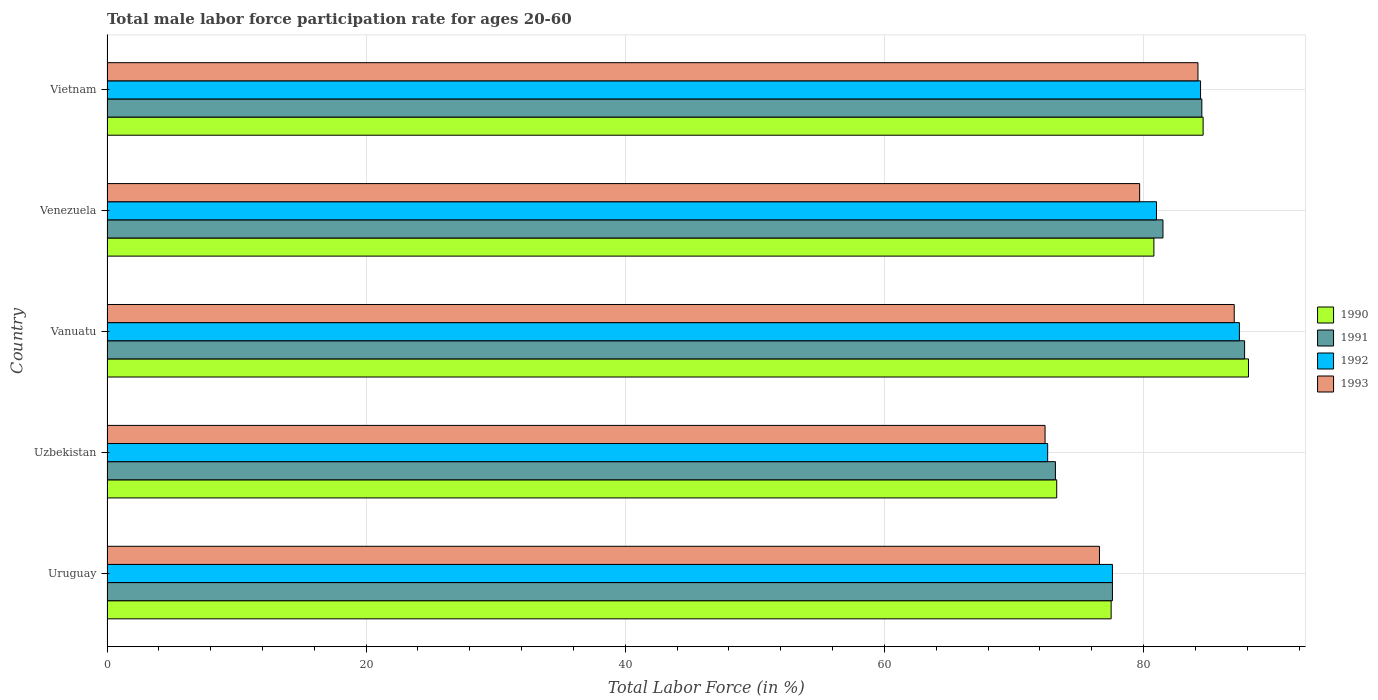How many bars are there on the 2nd tick from the top?
Provide a short and direct response. 4. What is the label of the 3rd group of bars from the top?
Ensure brevity in your answer.  Vanuatu. What is the male labor force participation rate in 1991 in Vietnam?
Make the answer very short. 84.5. Across all countries, what is the maximum male labor force participation rate in 1992?
Offer a very short reply. 87.4. Across all countries, what is the minimum male labor force participation rate in 1991?
Your response must be concise. 73.2. In which country was the male labor force participation rate in 1991 maximum?
Give a very brief answer. Vanuatu. In which country was the male labor force participation rate in 1992 minimum?
Provide a succinct answer. Uzbekistan. What is the total male labor force participation rate in 1993 in the graph?
Provide a succinct answer. 399.9. What is the difference between the male labor force participation rate in 1991 in Uruguay and that in Venezuela?
Keep it short and to the point. -3.9. What is the difference between the male labor force participation rate in 1990 in Venezuela and the male labor force participation rate in 1991 in Vietnam?
Provide a short and direct response. -3.7. What is the average male labor force participation rate in 1991 per country?
Offer a very short reply. 80.92. What is the difference between the male labor force participation rate in 1992 and male labor force participation rate in 1990 in Uruguay?
Your answer should be compact. 0.1. In how many countries, is the male labor force participation rate in 1991 greater than 72 %?
Provide a succinct answer. 5. What is the ratio of the male labor force participation rate in 1993 in Uzbekistan to that in Vietnam?
Your answer should be compact. 0.86. Is the difference between the male labor force participation rate in 1992 in Uruguay and Venezuela greater than the difference between the male labor force participation rate in 1990 in Uruguay and Venezuela?
Offer a very short reply. No. What is the difference between the highest and the second highest male labor force participation rate in 1991?
Provide a short and direct response. 3.3. What is the difference between the highest and the lowest male labor force participation rate in 1992?
Make the answer very short. 14.8. In how many countries, is the male labor force participation rate in 1992 greater than the average male labor force participation rate in 1992 taken over all countries?
Your response must be concise. 3. Is the sum of the male labor force participation rate in 1993 in Uzbekistan and Vanuatu greater than the maximum male labor force participation rate in 1991 across all countries?
Make the answer very short. Yes. Is it the case that in every country, the sum of the male labor force participation rate in 1990 and male labor force participation rate in 1992 is greater than the sum of male labor force participation rate in 1993 and male labor force participation rate in 1991?
Make the answer very short. No. What does the 3rd bar from the bottom in Vietnam represents?
Offer a terse response. 1992. Is it the case that in every country, the sum of the male labor force participation rate in 1993 and male labor force participation rate in 1990 is greater than the male labor force participation rate in 1992?
Make the answer very short. Yes. How many bars are there?
Offer a very short reply. 20. Are all the bars in the graph horizontal?
Keep it short and to the point. Yes. Are the values on the major ticks of X-axis written in scientific E-notation?
Your answer should be compact. No. Does the graph contain any zero values?
Provide a succinct answer. No. Where does the legend appear in the graph?
Ensure brevity in your answer.  Center right. How are the legend labels stacked?
Your response must be concise. Vertical. What is the title of the graph?
Give a very brief answer. Total male labor force participation rate for ages 20-60. Does "1987" appear as one of the legend labels in the graph?
Make the answer very short. No. What is the Total Labor Force (in %) in 1990 in Uruguay?
Make the answer very short. 77.5. What is the Total Labor Force (in %) of 1991 in Uruguay?
Offer a terse response. 77.6. What is the Total Labor Force (in %) in 1992 in Uruguay?
Make the answer very short. 77.6. What is the Total Labor Force (in %) in 1993 in Uruguay?
Your answer should be compact. 76.6. What is the Total Labor Force (in %) in 1990 in Uzbekistan?
Your response must be concise. 73.3. What is the Total Labor Force (in %) of 1991 in Uzbekistan?
Ensure brevity in your answer.  73.2. What is the Total Labor Force (in %) of 1992 in Uzbekistan?
Make the answer very short. 72.6. What is the Total Labor Force (in %) of 1993 in Uzbekistan?
Your answer should be compact. 72.4. What is the Total Labor Force (in %) in 1990 in Vanuatu?
Your response must be concise. 88.1. What is the Total Labor Force (in %) of 1991 in Vanuatu?
Your answer should be very brief. 87.8. What is the Total Labor Force (in %) in 1992 in Vanuatu?
Give a very brief answer. 87.4. What is the Total Labor Force (in %) of 1993 in Vanuatu?
Ensure brevity in your answer.  87. What is the Total Labor Force (in %) in 1990 in Venezuela?
Your response must be concise. 80.8. What is the Total Labor Force (in %) in 1991 in Venezuela?
Offer a terse response. 81.5. What is the Total Labor Force (in %) in 1992 in Venezuela?
Offer a very short reply. 81. What is the Total Labor Force (in %) in 1993 in Venezuela?
Your answer should be compact. 79.7. What is the Total Labor Force (in %) in 1990 in Vietnam?
Your response must be concise. 84.6. What is the Total Labor Force (in %) in 1991 in Vietnam?
Offer a very short reply. 84.5. What is the Total Labor Force (in %) of 1992 in Vietnam?
Offer a terse response. 84.4. What is the Total Labor Force (in %) of 1993 in Vietnam?
Provide a short and direct response. 84.2. Across all countries, what is the maximum Total Labor Force (in %) of 1990?
Provide a short and direct response. 88.1. Across all countries, what is the maximum Total Labor Force (in %) in 1991?
Your response must be concise. 87.8. Across all countries, what is the maximum Total Labor Force (in %) of 1992?
Ensure brevity in your answer.  87.4. Across all countries, what is the minimum Total Labor Force (in %) of 1990?
Your response must be concise. 73.3. Across all countries, what is the minimum Total Labor Force (in %) in 1991?
Your response must be concise. 73.2. Across all countries, what is the minimum Total Labor Force (in %) of 1992?
Offer a terse response. 72.6. Across all countries, what is the minimum Total Labor Force (in %) in 1993?
Your answer should be very brief. 72.4. What is the total Total Labor Force (in %) in 1990 in the graph?
Your answer should be very brief. 404.3. What is the total Total Labor Force (in %) of 1991 in the graph?
Your answer should be very brief. 404.6. What is the total Total Labor Force (in %) in 1992 in the graph?
Keep it short and to the point. 403. What is the total Total Labor Force (in %) of 1993 in the graph?
Ensure brevity in your answer.  399.9. What is the difference between the Total Labor Force (in %) of 1990 in Uruguay and that in Uzbekistan?
Your response must be concise. 4.2. What is the difference between the Total Labor Force (in %) of 1992 in Uruguay and that in Uzbekistan?
Ensure brevity in your answer.  5. What is the difference between the Total Labor Force (in %) in 1993 in Uruguay and that in Uzbekistan?
Give a very brief answer. 4.2. What is the difference between the Total Labor Force (in %) of 1990 in Uruguay and that in Vanuatu?
Keep it short and to the point. -10.6. What is the difference between the Total Labor Force (in %) of 1991 in Uruguay and that in Vanuatu?
Provide a short and direct response. -10.2. What is the difference between the Total Labor Force (in %) of 1992 in Uruguay and that in Vanuatu?
Give a very brief answer. -9.8. What is the difference between the Total Labor Force (in %) of 1993 in Uruguay and that in Vanuatu?
Make the answer very short. -10.4. What is the difference between the Total Labor Force (in %) of 1992 in Uruguay and that in Venezuela?
Offer a very short reply. -3.4. What is the difference between the Total Labor Force (in %) of 1993 in Uruguay and that in Venezuela?
Provide a short and direct response. -3.1. What is the difference between the Total Labor Force (in %) in 1990 in Uruguay and that in Vietnam?
Make the answer very short. -7.1. What is the difference between the Total Labor Force (in %) of 1992 in Uruguay and that in Vietnam?
Give a very brief answer. -6.8. What is the difference between the Total Labor Force (in %) in 1993 in Uruguay and that in Vietnam?
Ensure brevity in your answer.  -7.6. What is the difference between the Total Labor Force (in %) in 1990 in Uzbekistan and that in Vanuatu?
Make the answer very short. -14.8. What is the difference between the Total Labor Force (in %) in 1991 in Uzbekistan and that in Vanuatu?
Provide a short and direct response. -14.6. What is the difference between the Total Labor Force (in %) in 1992 in Uzbekistan and that in Vanuatu?
Keep it short and to the point. -14.8. What is the difference between the Total Labor Force (in %) of 1993 in Uzbekistan and that in Vanuatu?
Ensure brevity in your answer.  -14.6. What is the difference between the Total Labor Force (in %) of 1991 in Uzbekistan and that in Venezuela?
Make the answer very short. -8.3. What is the difference between the Total Labor Force (in %) in 1993 in Uzbekistan and that in Venezuela?
Your answer should be very brief. -7.3. What is the difference between the Total Labor Force (in %) of 1990 in Uzbekistan and that in Vietnam?
Offer a terse response. -11.3. What is the difference between the Total Labor Force (in %) in 1991 in Uzbekistan and that in Vietnam?
Offer a very short reply. -11.3. What is the difference between the Total Labor Force (in %) of 1992 in Uzbekistan and that in Vietnam?
Offer a very short reply. -11.8. What is the difference between the Total Labor Force (in %) of 1993 in Uzbekistan and that in Vietnam?
Make the answer very short. -11.8. What is the difference between the Total Labor Force (in %) in 1990 in Vanuatu and that in Venezuela?
Offer a terse response. 7.3. What is the difference between the Total Labor Force (in %) of 1991 in Vanuatu and that in Venezuela?
Make the answer very short. 6.3. What is the difference between the Total Labor Force (in %) of 1993 in Vanuatu and that in Venezuela?
Provide a succinct answer. 7.3. What is the difference between the Total Labor Force (in %) in 1990 in Vanuatu and that in Vietnam?
Your answer should be compact. 3.5. What is the difference between the Total Labor Force (in %) of 1991 in Vanuatu and that in Vietnam?
Your answer should be very brief. 3.3. What is the difference between the Total Labor Force (in %) of 1992 in Vanuatu and that in Vietnam?
Make the answer very short. 3. What is the difference between the Total Labor Force (in %) in 1993 in Vanuatu and that in Vietnam?
Keep it short and to the point. 2.8. What is the difference between the Total Labor Force (in %) of 1990 in Venezuela and that in Vietnam?
Give a very brief answer. -3.8. What is the difference between the Total Labor Force (in %) in 1991 in Venezuela and that in Vietnam?
Provide a succinct answer. -3. What is the difference between the Total Labor Force (in %) in 1992 in Venezuela and that in Vietnam?
Ensure brevity in your answer.  -3.4. What is the difference between the Total Labor Force (in %) in 1993 in Venezuela and that in Vietnam?
Keep it short and to the point. -4.5. What is the difference between the Total Labor Force (in %) of 1990 in Uruguay and the Total Labor Force (in %) of 1992 in Uzbekistan?
Provide a short and direct response. 4.9. What is the difference between the Total Labor Force (in %) in 1991 in Uruguay and the Total Labor Force (in %) in 1992 in Uzbekistan?
Keep it short and to the point. 5. What is the difference between the Total Labor Force (in %) in 1992 in Uruguay and the Total Labor Force (in %) in 1993 in Uzbekistan?
Make the answer very short. 5.2. What is the difference between the Total Labor Force (in %) of 1991 in Uruguay and the Total Labor Force (in %) of 1993 in Vanuatu?
Offer a very short reply. -9.4. What is the difference between the Total Labor Force (in %) of 1990 in Uruguay and the Total Labor Force (in %) of 1991 in Venezuela?
Your answer should be compact. -4. What is the difference between the Total Labor Force (in %) in 1990 in Uruguay and the Total Labor Force (in %) in 1992 in Venezuela?
Your answer should be very brief. -3.5. What is the difference between the Total Labor Force (in %) of 1992 in Uruguay and the Total Labor Force (in %) of 1993 in Venezuela?
Give a very brief answer. -2.1. What is the difference between the Total Labor Force (in %) of 1990 in Uruguay and the Total Labor Force (in %) of 1991 in Vietnam?
Your answer should be very brief. -7. What is the difference between the Total Labor Force (in %) in 1990 in Uruguay and the Total Labor Force (in %) in 1993 in Vietnam?
Your answer should be compact. -6.7. What is the difference between the Total Labor Force (in %) in 1991 in Uruguay and the Total Labor Force (in %) in 1992 in Vietnam?
Provide a succinct answer. -6.8. What is the difference between the Total Labor Force (in %) in 1991 in Uruguay and the Total Labor Force (in %) in 1993 in Vietnam?
Your answer should be compact. -6.6. What is the difference between the Total Labor Force (in %) of 1990 in Uzbekistan and the Total Labor Force (in %) of 1991 in Vanuatu?
Offer a terse response. -14.5. What is the difference between the Total Labor Force (in %) of 1990 in Uzbekistan and the Total Labor Force (in %) of 1992 in Vanuatu?
Provide a short and direct response. -14.1. What is the difference between the Total Labor Force (in %) of 1990 in Uzbekistan and the Total Labor Force (in %) of 1993 in Vanuatu?
Provide a short and direct response. -13.7. What is the difference between the Total Labor Force (in %) of 1991 in Uzbekistan and the Total Labor Force (in %) of 1993 in Vanuatu?
Your response must be concise. -13.8. What is the difference between the Total Labor Force (in %) in 1992 in Uzbekistan and the Total Labor Force (in %) in 1993 in Vanuatu?
Provide a succinct answer. -14.4. What is the difference between the Total Labor Force (in %) of 1990 in Uzbekistan and the Total Labor Force (in %) of 1991 in Venezuela?
Offer a terse response. -8.2. What is the difference between the Total Labor Force (in %) in 1990 in Uzbekistan and the Total Labor Force (in %) in 1992 in Venezuela?
Make the answer very short. -7.7. What is the difference between the Total Labor Force (in %) of 1991 in Uzbekistan and the Total Labor Force (in %) of 1992 in Venezuela?
Make the answer very short. -7.8. What is the difference between the Total Labor Force (in %) in 1991 in Uzbekistan and the Total Labor Force (in %) in 1992 in Vietnam?
Offer a very short reply. -11.2. What is the difference between the Total Labor Force (in %) in 1991 in Uzbekistan and the Total Labor Force (in %) in 1993 in Vietnam?
Your answer should be compact. -11. What is the difference between the Total Labor Force (in %) of 1992 in Uzbekistan and the Total Labor Force (in %) of 1993 in Vietnam?
Your answer should be very brief. -11.6. What is the difference between the Total Labor Force (in %) in 1990 in Vanuatu and the Total Labor Force (in %) in 1991 in Venezuela?
Your answer should be compact. 6.6. What is the difference between the Total Labor Force (in %) of 1990 in Vanuatu and the Total Labor Force (in %) of 1992 in Venezuela?
Offer a very short reply. 7.1. What is the difference between the Total Labor Force (in %) in 1991 in Vanuatu and the Total Labor Force (in %) in 1992 in Venezuela?
Ensure brevity in your answer.  6.8. What is the difference between the Total Labor Force (in %) of 1991 in Vanuatu and the Total Labor Force (in %) of 1993 in Venezuela?
Give a very brief answer. 8.1. What is the difference between the Total Labor Force (in %) of 1990 in Vanuatu and the Total Labor Force (in %) of 1993 in Vietnam?
Provide a succinct answer. 3.9. What is the difference between the Total Labor Force (in %) of 1991 in Vanuatu and the Total Labor Force (in %) of 1992 in Vietnam?
Keep it short and to the point. 3.4. What is the difference between the Total Labor Force (in %) in 1991 in Vanuatu and the Total Labor Force (in %) in 1993 in Vietnam?
Your answer should be very brief. 3.6. What is the difference between the Total Labor Force (in %) of 1990 in Venezuela and the Total Labor Force (in %) of 1992 in Vietnam?
Offer a very short reply. -3.6. What is the difference between the Total Labor Force (in %) of 1990 in Venezuela and the Total Labor Force (in %) of 1993 in Vietnam?
Keep it short and to the point. -3.4. What is the difference between the Total Labor Force (in %) in 1992 in Venezuela and the Total Labor Force (in %) in 1993 in Vietnam?
Make the answer very short. -3.2. What is the average Total Labor Force (in %) in 1990 per country?
Ensure brevity in your answer.  80.86. What is the average Total Labor Force (in %) of 1991 per country?
Provide a short and direct response. 80.92. What is the average Total Labor Force (in %) in 1992 per country?
Provide a succinct answer. 80.6. What is the average Total Labor Force (in %) in 1993 per country?
Give a very brief answer. 79.98. What is the difference between the Total Labor Force (in %) in 1991 and Total Labor Force (in %) in 1992 in Uruguay?
Make the answer very short. 0. What is the difference between the Total Labor Force (in %) of 1991 and Total Labor Force (in %) of 1993 in Uruguay?
Make the answer very short. 1. What is the difference between the Total Labor Force (in %) in 1992 and Total Labor Force (in %) in 1993 in Uruguay?
Ensure brevity in your answer.  1. What is the difference between the Total Labor Force (in %) of 1990 and Total Labor Force (in %) of 1993 in Uzbekistan?
Keep it short and to the point. 0.9. What is the difference between the Total Labor Force (in %) in 1992 and Total Labor Force (in %) in 1993 in Uzbekistan?
Your answer should be compact. 0.2. What is the difference between the Total Labor Force (in %) of 1990 and Total Labor Force (in %) of 1992 in Vanuatu?
Offer a very short reply. 0.7. What is the difference between the Total Labor Force (in %) in 1990 and Total Labor Force (in %) in 1993 in Vanuatu?
Provide a succinct answer. 1.1. What is the difference between the Total Labor Force (in %) in 1990 and Total Labor Force (in %) in 1992 in Venezuela?
Ensure brevity in your answer.  -0.2. What is the difference between the Total Labor Force (in %) of 1991 and Total Labor Force (in %) of 1993 in Venezuela?
Offer a terse response. 1.8. What is the difference between the Total Labor Force (in %) of 1992 and Total Labor Force (in %) of 1993 in Venezuela?
Your answer should be very brief. 1.3. What is the difference between the Total Labor Force (in %) in 1990 and Total Labor Force (in %) in 1992 in Vietnam?
Offer a very short reply. 0.2. What is the difference between the Total Labor Force (in %) in 1991 and Total Labor Force (in %) in 1993 in Vietnam?
Your response must be concise. 0.3. What is the ratio of the Total Labor Force (in %) in 1990 in Uruguay to that in Uzbekistan?
Provide a succinct answer. 1.06. What is the ratio of the Total Labor Force (in %) of 1991 in Uruguay to that in Uzbekistan?
Offer a terse response. 1.06. What is the ratio of the Total Labor Force (in %) of 1992 in Uruguay to that in Uzbekistan?
Provide a succinct answer. 1.07. What is the ratio of the Total Labor Force (in %) in 1993 in Uruguay to that in Uzbekistan?
Offer a terse response. 1.06. What is the ratio of the Total Labor Force (in %) of 1990 in Uruguay to that in Vanuatu?
Your response must be concise. 0.88. What is the ratio of the Total Labor Force (in %) in 1991 in Uruguay to that in Vanuatu?
Offer a very short reply. 0.88. What is the ratio of the Total Labor Force (in %) in 1992 in Uruguay to that in Vanuatu?
Provide a succinct answer. 0.89. What is the ratio of the Total Labor Force (in %) in 1993 in Uruguay to that in Vanuatu?
Offer a very short reply. 0.88. What is the ratio of the Total Labor Force (in %) of 1990 in Uruguay to that in Venezuela?
Provide a succinct answer. 0.96. What is the ratio of the Total Labor Force (in %) in 1991 in Uruguay to that in Venezuela?
Keep it short and to the point. 0.95. What is the ratio of the Total Labor Force (in %) of 1992 in Uruguay to that in Venezuela?
Offer a terse response. 0.96. What is the ratio of the Total Labor Force (in %) of 1993 in Uruguay to that in Venezuela?
Offer a very short reply. 0.96. What is the ratio of the Total Labor Force (in %) in 1990 in Uruguay to that in Vietnam?
Offer a terse response. 0.92. What is the ratio of the Total Labor Force (in %) of 1991 in Uruguay to that in Vietnam?
Your response must be concise. 0.92. What is the ratio of the Total Labor Force (in %) in 1992 in Uruguay to that in Vietnam?
Your answer should be compact. 0.92. What is the ratio of the Total Labor Force (in %) of 1993 in Uruguay to that in Vietnam?
Give a very brief answer. 0.91. What is the ratio of the Total Labor Force (in %) in 1990 in Uzbekistan to that in Vanuatu?
Provide a succinct answer. 0.83. What is the ratio of the Total Labor Force (in %) in 1991 in Uzbekistan to that in Vanuatu?
Keep it short and to the point. 0.83. What is the ratio of the Total Labor Force (in %) of 1992 in Uzbekistan to that in Vanuatu?
Your answer should be compact. 0.83. What is the ratio of the Total Labor Force (in %) of 1993 in Uzbekistan to that in Vanuatu?
Your answer should be compact. 0.83. What is the ratio of the Total Labor Force (in %) in 1990 in Uzbekistan to that in Venezuela?
Your answer should be compact. 0.91. What is the ratio of the Total Labor Force (in %) of 1991 in Uzbekistan to that in Venezuela?
Your answer should be very brief. 0.9. What is the ratio of the Total Labor Force (in %) in 1992 in Uzbekistan to that in Venezuela?
Provide a succinct answer. 0.9. What is the ratio of the Total Labor Force (in %) of 1993 in Uzbekistan to that in Venezuela?
Ensure brevity in your answer.  0.91. What is the ratio of the Total Labor Force (in %) in 1990 in Uzbekistan to that in Vietnam?
Keep it short and to the point. 0.87. What is the ratio of the Total Labor Force (in %) of 1991 in Uzbekistan to that in Vietnam?
Your answer should be very brief. 0.87. What is the ratio of the Total Labor Force (in %) in 1992 in Uzbekistan to that in Vietnam?
Your response must be concise. 0.86. What is the ratio of the Total Labor Force (in %) in 1993 in Uzbekistan to that in Vietnam?
Offer a very short reply. 0.86. What is the ratio of the Total Labor Force (in %) of 1990 in Vanuatu to that in Venezuela?
Your response must be concise. 1.09. What is the ratio of the Total Labor Force (in %) in 1991 in Vanuatu to that in Venezuela?
Your response must be concise. 1.08. What is the ratio of the Total Labor Force (in %) in 1992 in Vanuatu to that in Venezuela?
Your response must be concise. 1.08. What is the ratio of the Total Labor Force (in %) of 1993 in Vanuatu to that in Venezuela?
Give a very brief answer. 1.09. What is the ratio of the Total Labor Force (in %) of 1990 in Vanuatu to that in Vietnam?
Your answer should be very brief. 1.04. What is the ratio of the Total Labor Force (in %) in 1991 in Vanuatu to that in Vietnam?
Provide a succinct answer. 1.04. What is the ratio of the Total Labor Force (in %) of 1992 in Vanuatu to that in Vietnam?
Offer a terse response. 1.04. What is the ratio of the Total Labor Force (in %) of 1990 in Venezuela to that in Vietnam?
Give a very brief answer. 0.96. What is the ratio of the Total Labor Force (in %) in 1991 in Venezuela to that in Vietnam?
Your response must be concise. 0.96. What is the ratio of the Total Labor Force (in %) in 1992 in Venezuela to that in Vietnam?
Offer a terse response. 0.96. What is the ratio of the Total Labor Force (in %) in 1993 in Venezuela to that in Vietnam?
Your answer should be very brief. 0.95. What is the difference between the highest and the second highest Total Labor Force (in %) in 1990?
Give a very brief answer. 3.5. What is the difference between the highest and the second highest Total Labor Force (in %) in 1991?
Make the answer very short. 3.3. What is the difference between the highest and the second highest Total Labor Force (in %) in 1993?
Your response must be concise. 2.8. What is the difference between the highest and the lowest Total Labor Force (in %) in 1990?
Your response must be concise. 14.8. What is the difference between the highest and the lowest Total Labor Force (in %) of 1993?
Keep it short and to the point. 14.6. 